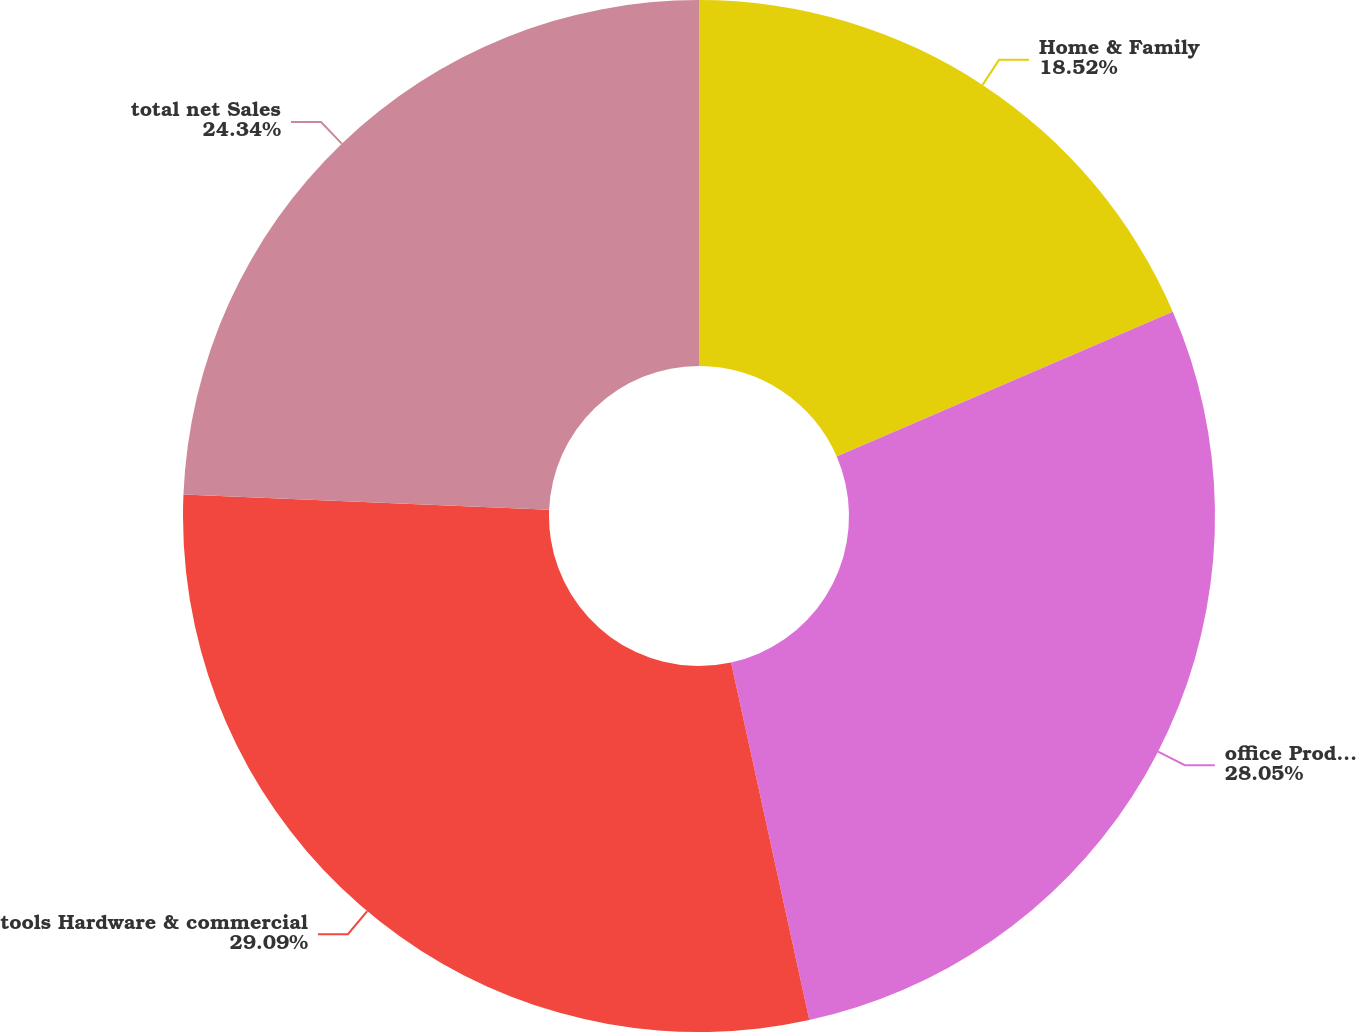Convert chart. <chart><loc_0><loc_0><loc_500><loc_500><pie_chart><fcel>Home & Family<fcel>office Products<fcel>tools Hardware & commercial<fcel>total net Sales<nl><fcel>18.52%<fcel>28.05%<fcel>29.09%<fcel>24.34%<nl></chart> 